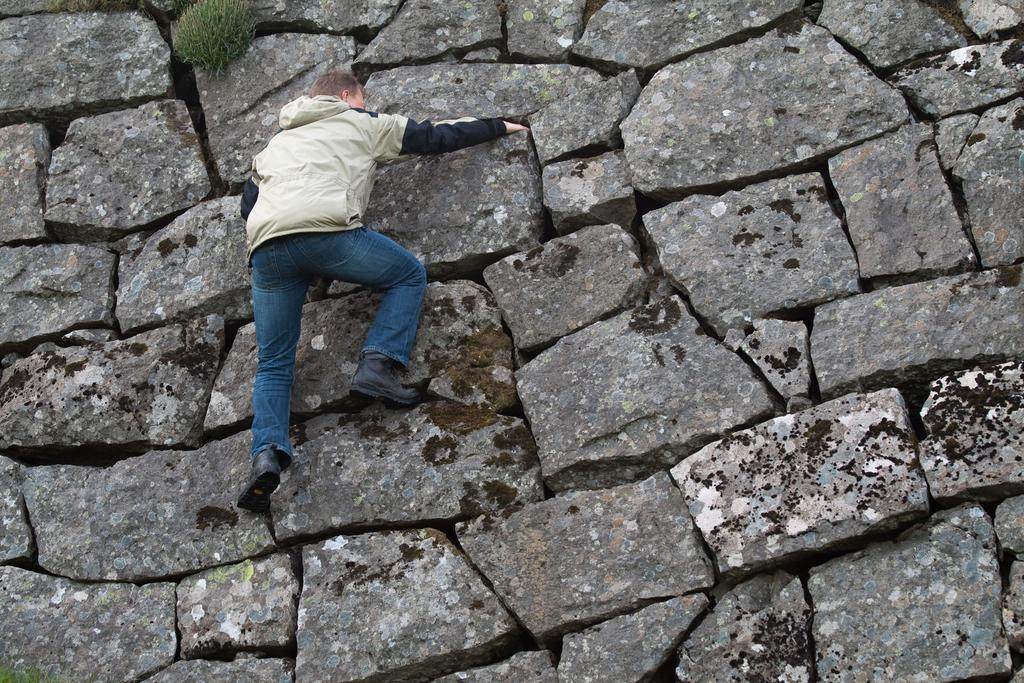What is the main subject of the image? There is a man in the image. What is the man doing in the image? The man is climbing a stone wall. How many bees can be seen buzzing around the man while he is climbing the wall? There are no bees present in the image; the man is simply climbing a stone wall. 